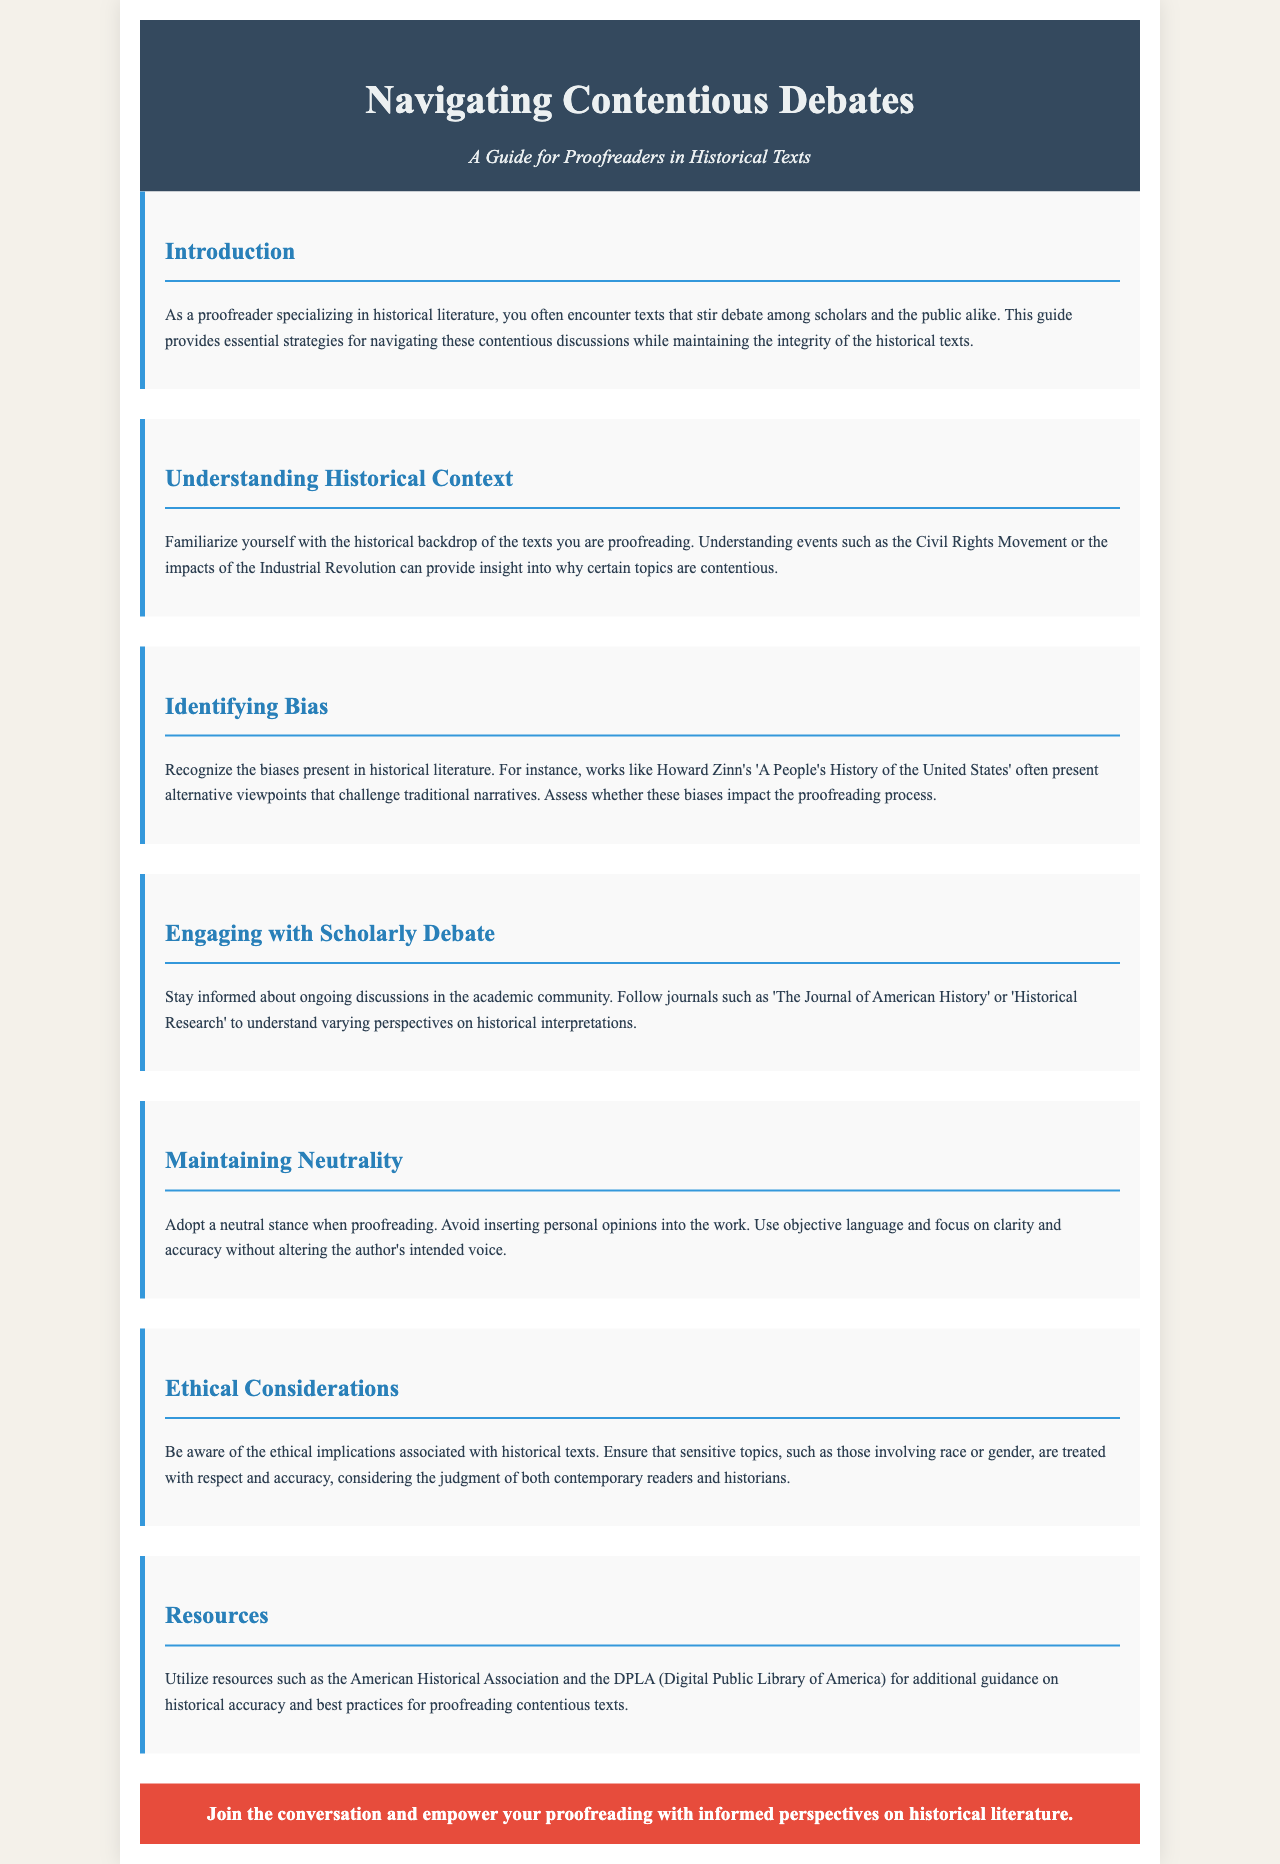What is the title of the brochure? The title is prominently displayed at the top of the document in a large font.
Answer: Navigating Contentious Debates: A Guide for Proofreaders in Historical Texts Who is the intended audience for this guide? The introduction specifies the target audience of the guide clearly.
Answer: Proofreaders What are the two journals mentioned for engaging with scholarly debate? The document lists specific journals in the relevant section.
Answer: The Journal of American History, Historical Research What is one ethical consideration mentioned for proofreading historical texts? The section on ethical considerations highlights important aspects that proofreaders should note.
Answer: Respect and accuracy Which historical movements are suggested for familiarization with the historical context? The document provides examples of movements relevant to the understanding of contentious topics.
Answer: Civil Rights Movement, Industrial Revolution What stance should proofreaders adopt when proofreading texts? The guide emphasizes the importance of neutrality in the proofreading process.
Answer: Neutral stance What kind of resources does the document suggest utilizing? The resources section indicates specific organizations for additional guidance.
Answer: American Historical Association, DPLA What is the call to action at the end of the brochure? The concluding remark encourages engagement with the purpose of the brochure.
Answer: Join the conversation and empower your proofreading with informed perspectives on historical literature 